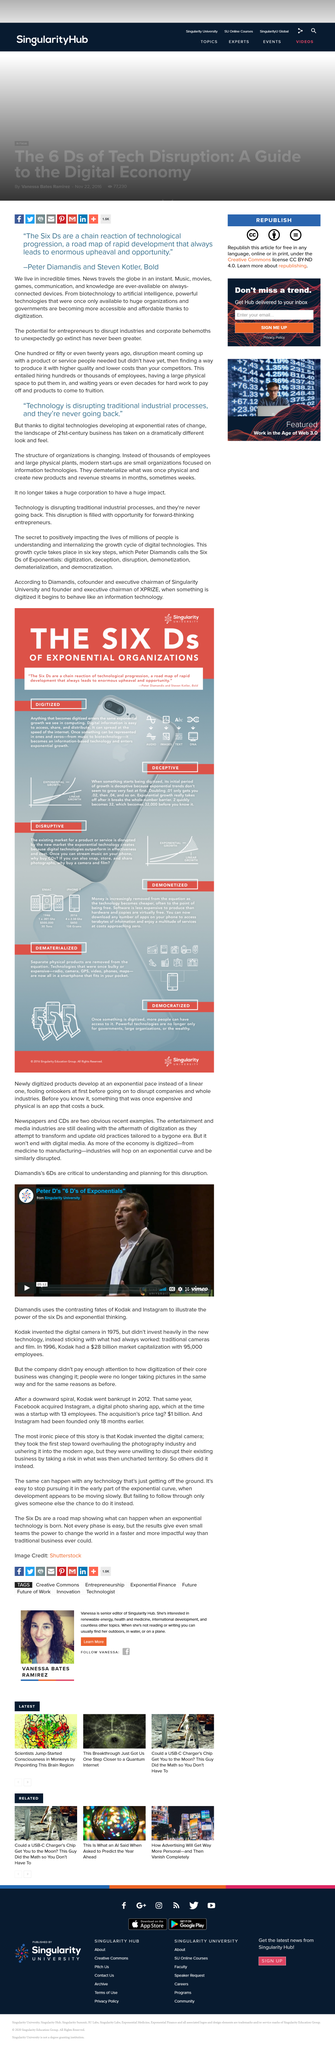Indicate a few pertinent items in this graphic. Kodak invented the digital camera in 1975. This picture depicts Peter Diamandis. The invention of the digital camera is widely attributed to Kodak. 